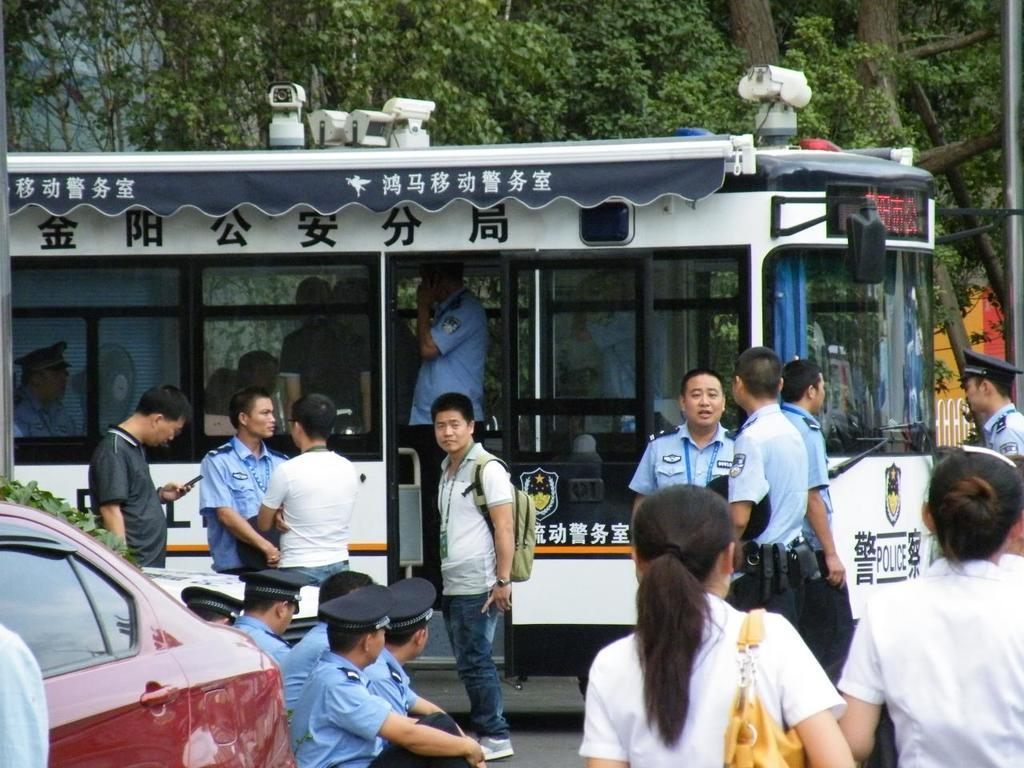<image>
Offer a succinct explanation of the picture presented. People standing in front of a bus that has the word POLICE on it. 